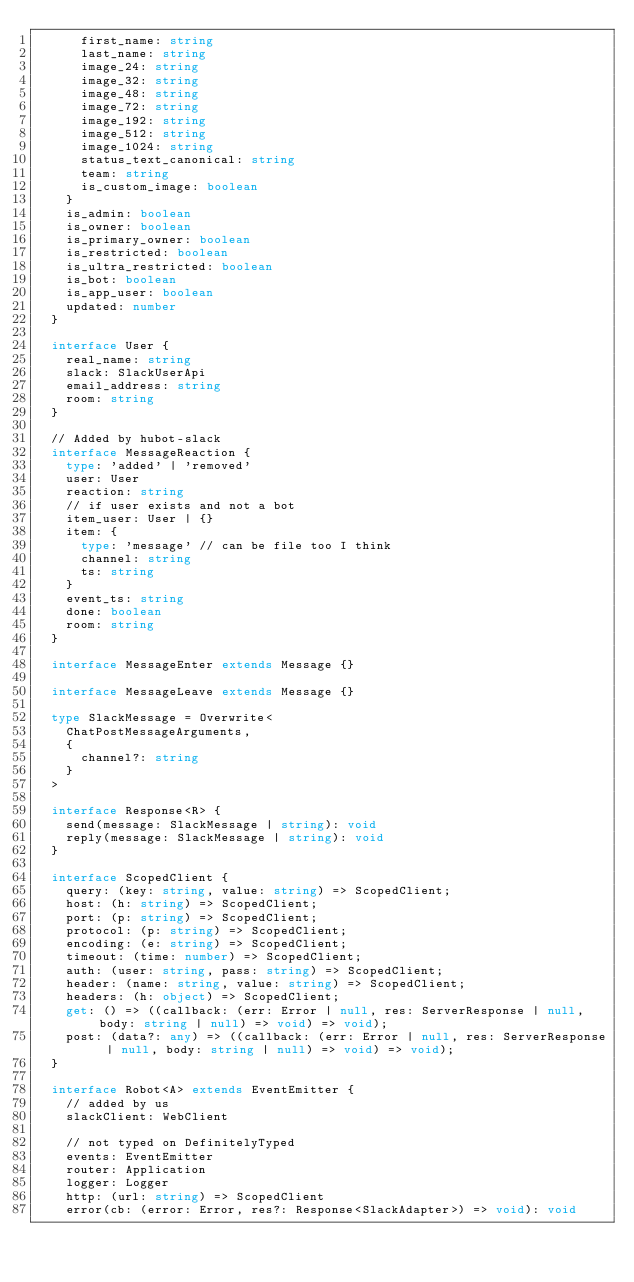Convert code to text. <code><loc_0><loc_0><loc_500><loc_500><_TypeScript_>      first_name: string
      last_name: string
      image_24: string
      image_32: string
      image_48: string
      image_72: string
      image_192: string
      image_512: string
      image_1024: string
      status_text_canonical: string
      team: string
      is_custom_image: boolean
    }
    is_admin: boolean
    is_owner: boolean
    is_primary_owner: boolean
    is_restricted: boolean
    is_ultra_restricted: boolean
    is_bot: boolean
    is_app_user: boolean
    updated: number
  }

  interface User {
    real_name: string
    slack: SlackUserApi
    email_address: string
    room: string
  }

  // Added by hubot-slack
  interface MessageReaction {
    type: 'added' | 'removed'
    user: User
    reaction: string
    // if user exists and not a bot
    item_user: User | {}
    item: {
      type: 'message' // can be file too I think
      channel: string
      ts: string
    }
    event_ts: string
    done: boolean
    room: string
  }

  interface MessageEnter extends Message {}

  interface MessageLeave extends Message {}

  type SlackMessage = Overwrite<
    ChatPostMessageArguments,
    {
      channel?: string
    }
  >

  interface Response<R> {
    send(message: SlackMessage | string): void
    reply(message: SlackMessage | string): void
  }

  interface ScopedClient {
    query: (key: string, value: string) => ScopedClient;
    host: (h: string) => ScopedClient;
    port: (p: string) => ScopedClient;
    protocol: (p: string) => ScopedClient;
    encoding: (e: string) => ScopedClient;
    timeout: (time: number) => ScopedClient;
    auth: (user: string, pass: string) => ScopedClient;
    header: (name: string, value: string) => ScopedClient;
    headers: (h: object) => ScopedClient;
    get: () => ((callback: (err: Error | null, res: ServerResponse | null, body: string | null) => void) => void);
    post: (data?: any) => ((callback: (err: Error | null, res: ServerResponse | null, body: string | null) => void) => void);
  }

  interface Robot<A> extends EventEmitter {
    // added by us
    slackClient: WebClient

    // not typed on DefinitelyTyped
    events: EventEmitter
    router: Application
    logger: Logger
    http: (url: string) => ScopedClient
    error(cb: (error: Error, res?: Response<SlackAdapter>) => void): void</code> 